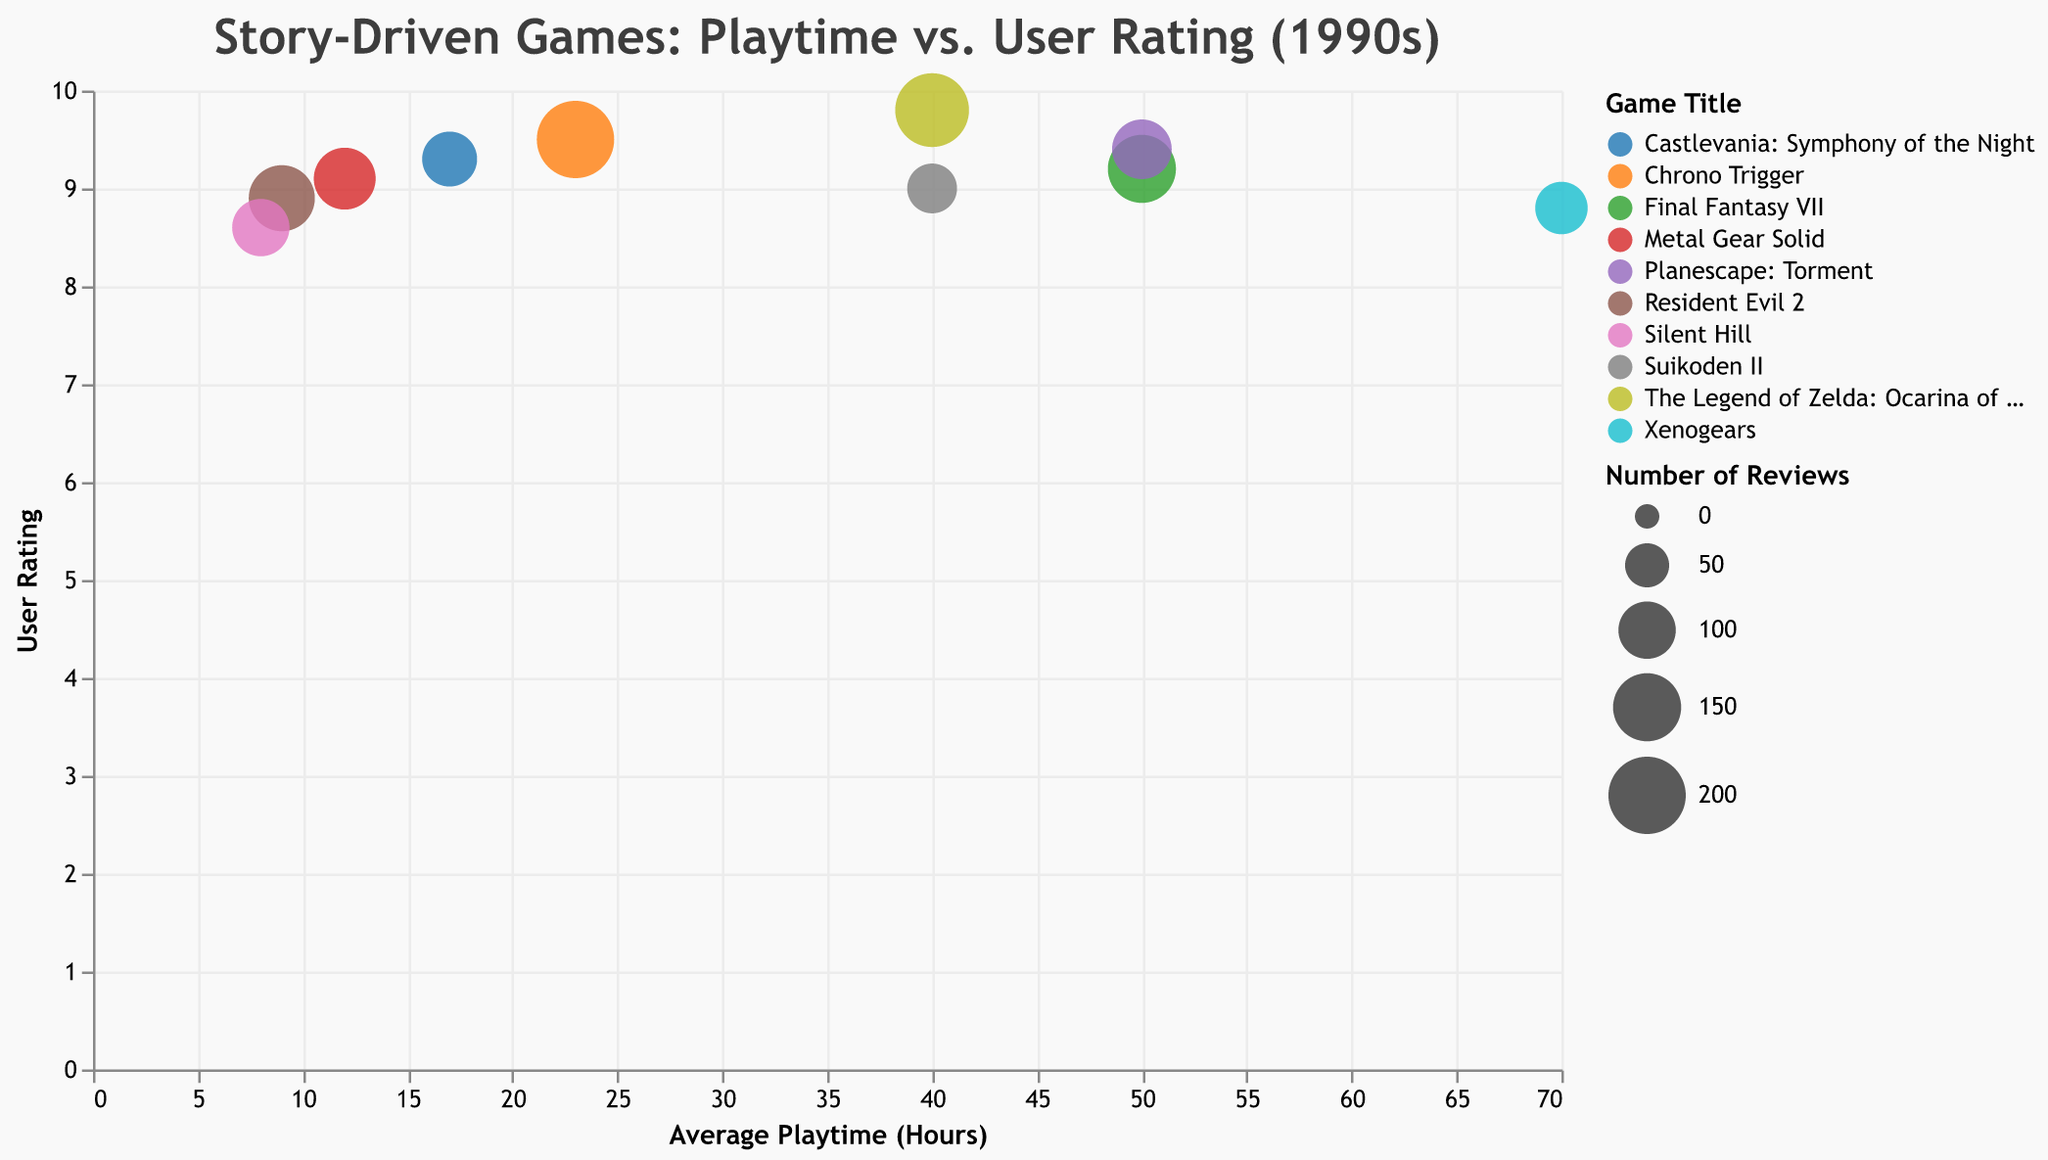How many games have an average playtime of 40 hours? Look at the x-axis for points located at 40 hours and count the number of such points. There are two points at 40 hours, representing "The Legend of Zelda: Ocarina of Time" and "Suikoden II."
Answer: 2 Which game has the highest user rating? Check the y-axis and identify the game with the highest value. "The Legend of Zelda: Ocarina of Time" has a user rating of 9.8.
Answer: The Legend of Zelda: Ocarina of Time What is the user rating and number of reviews for "Final Fantasy VII"? Locate "Final Fantasy VII" on the chart and refer to the y-axis for the user rating and the size of the bubble for the number of reviews. "Final Fantasy VII" has a user rating of 9.2 and 150 reviews.
Answer: 9.2, 150 Which games have over 100 reviews? Check the legend that signifies the number of reviews and identify bubbles larger than the size representing approximately 100 reviews. The games are "Final Fantasy VII," "Chrono Trigger," "The Legend of Zelda: Ocarina of Time," "Metal Gear Solid," "Resident Evil 2," and "Planescape: Torment."
Answer: Final Fantasy VII, Chrono Trigger, The Legend of Zelda: Ocarina of Time, Metal Gear Solid, Resident Evil 2, Planescape: Torment What is the average playtime of the game with the lowest user rating? Identify the game with the lowest position on the y-axis (lowest user rating), which is "Silent Hill" with a user rating of 8.6. Its average playtime is 8 hours.
Answer: 8 hours Compare the user ratings of "Chrono Trigger" and "Planescape: Torment." Which is higher? Locate both games on the y-axis and compare their values. "Chrono Trigger" has a user rating of 9.5, and "Planescape: Torment" has a rating of 9.4.
Answer: Chrono Trigger How much higher is the average playtime of "Xenogears" compared to "Resident Evil 2"? Refer to the x-axis to find the average playtime of both games. "Xenogears" has 70 hours, and "Resident Evil 2" has 9 hours. The difference is 70 - 9 = 61 hours.
Answer: 61 hours What is the sum of the user ratings for "Final Fantasy VII," "Chrono Trigger," and "Metal Gear Solid"? Identify the user ratings of each game and sum them up. The ratings are 9.2 (Final Fantasy VII), 9.5 (Chrono Trigger), and 9.1 (Metal Gear Solid). The total is 9.2 + 9.5 + 9.1 = 27.8.
Answer: 27.8 Which game has the largest bubble size and what does it represent? Locate the largest bubble on the chart, which represents "Chrono Trigger." The size represents the number of reviews, which is 200.
Answer: Chrono Trigger (200 reviews) Does a higher average playtime correlate with higher user ratings? Observe the scatter pattern of the bubbles. While there is no strict trend, games with higher user ratings (like "The Legend of Zelda: Ocarina of Time" and "Chrono Trigger") have varied playtimes.
Answer: No strict correlation 